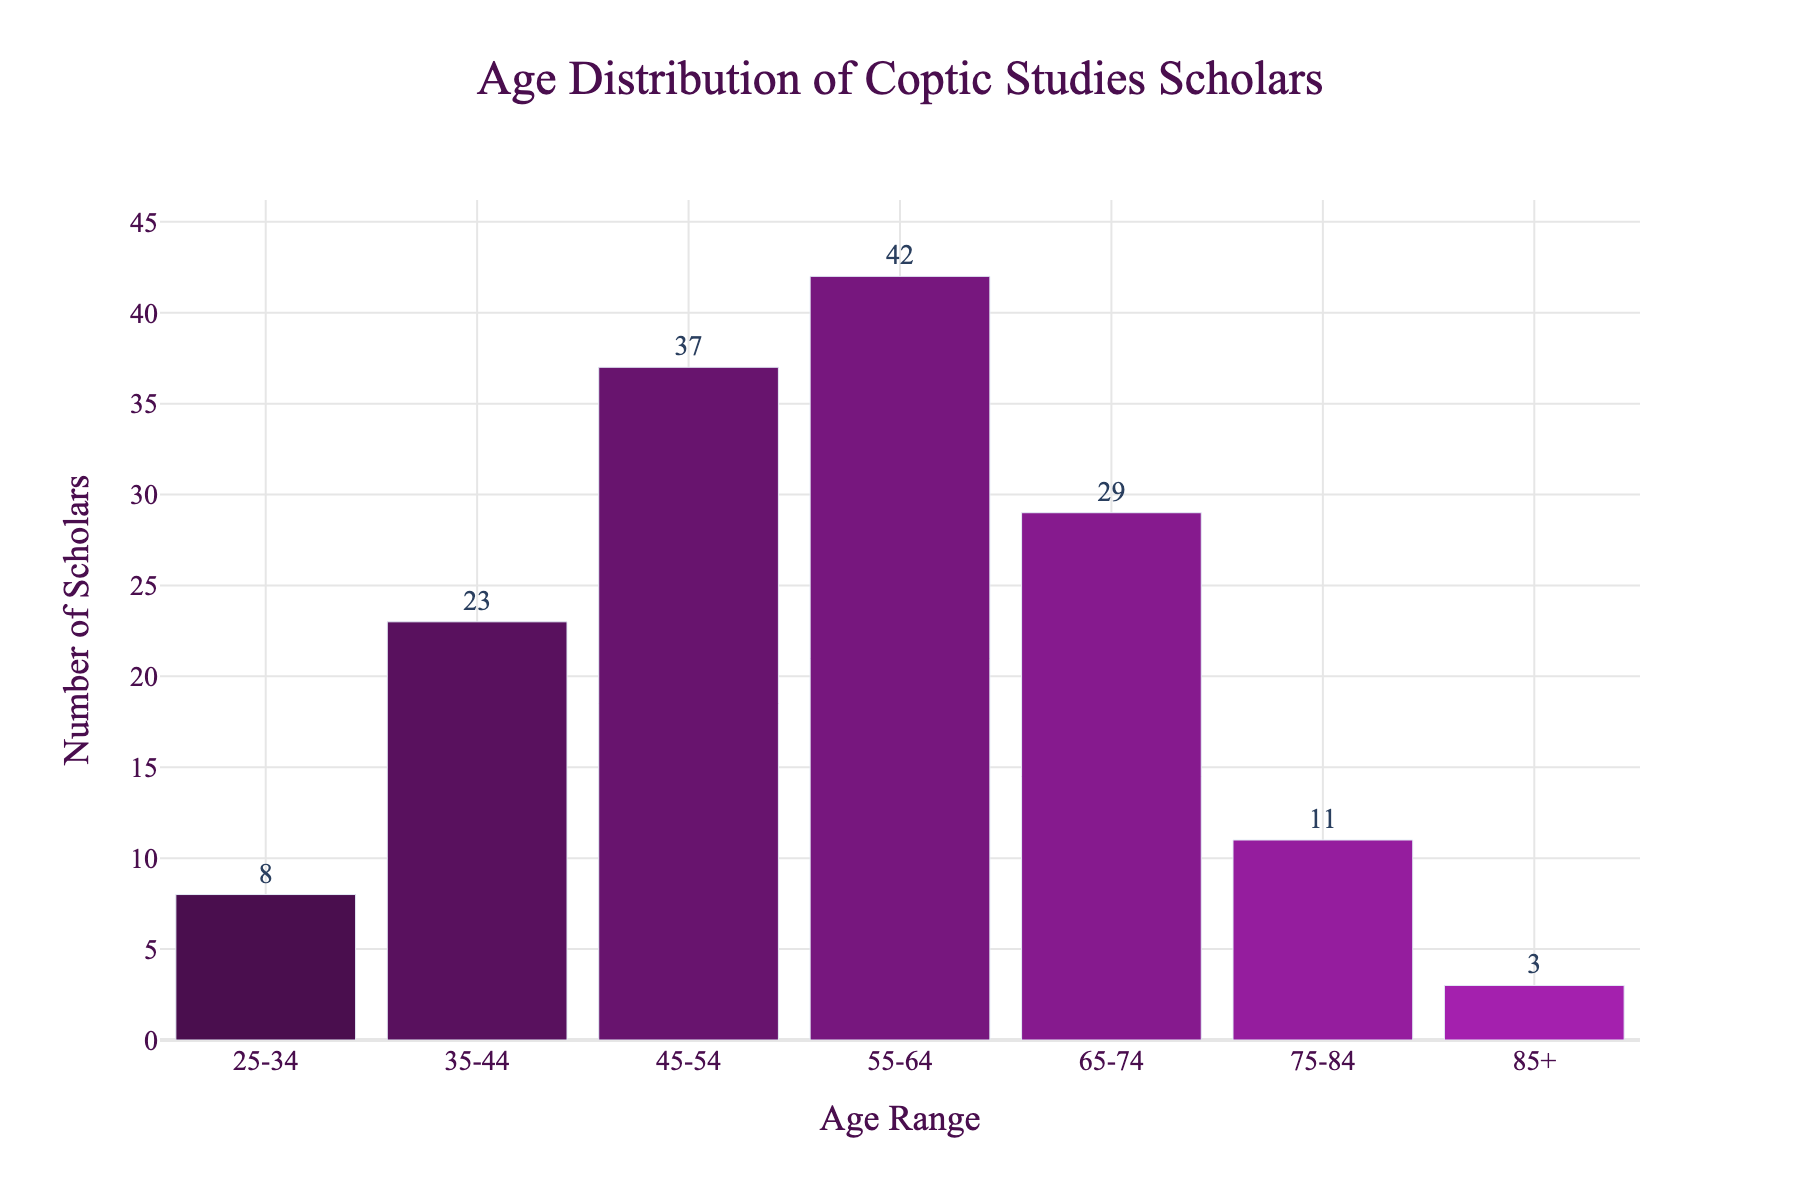What's the title of the figure? The title is clearly visible at the top of the figure. It states the overall subject or focus of the visualization.
Answer: Age Distribution of Coptic Studies Scholars Which age range has the highest number of scholars? By looking at the heights of all the bars, we can determine that the tallest bar corresponds to the age range with the highest number of scholars.
Answer: 55-64 How many scholars are there in the 45-54 age range? The number displayed above the bar labeled '45-54' indicates the count of scholars in this age range.
Answer: 37 What is the total number of scholars in the age ranges 65-74 and 75-84 combined? Add the number of scholars in the 65-74 range to the number in the 75-84 range: 29 (65-74) + 11 (75-84) = 40.
Answer: 40 What is the average number of scholars per age range? Sum the number of scholars in all age ranges and then divide by the number of age ranges. (8 + 23 + 37 + 42 + 29 + 11 + 3) / 7 = 153 / 7 = approximately 21.86
Answer: 21.86 How many more scholars are there in the 55-64 age range compared to the 25-34 age range? Subtract the number of scholars in the 25-34 range from the number in the 55-64 range: 42 - 8 = 34.
Answer: 34 Which age range has the second highest number of scholars? After identifying the age range with the highest number of scholars (55-64), the second highest is the next tallest bar, which is 45-54.
Answer: 45-54 What is the least represented age range in the figure? The shortest bar represents the age range with the fewest number of scholars.
Answer: 85+ Is the number of scholars aged 35-44 greater than the number aged 65-74? Compare the numbers of scholars in the 35-44 and 65-74 age ranges: 23 (35-44) < 29 (65-74).
Answer: No What percentage of scholars are under 35 years old? Divide the number of scholars under 35 by the total number of scholars and multiply by 100. (8) / 153 * 100 ≈ 5.23%.
Answer: 5.23% 